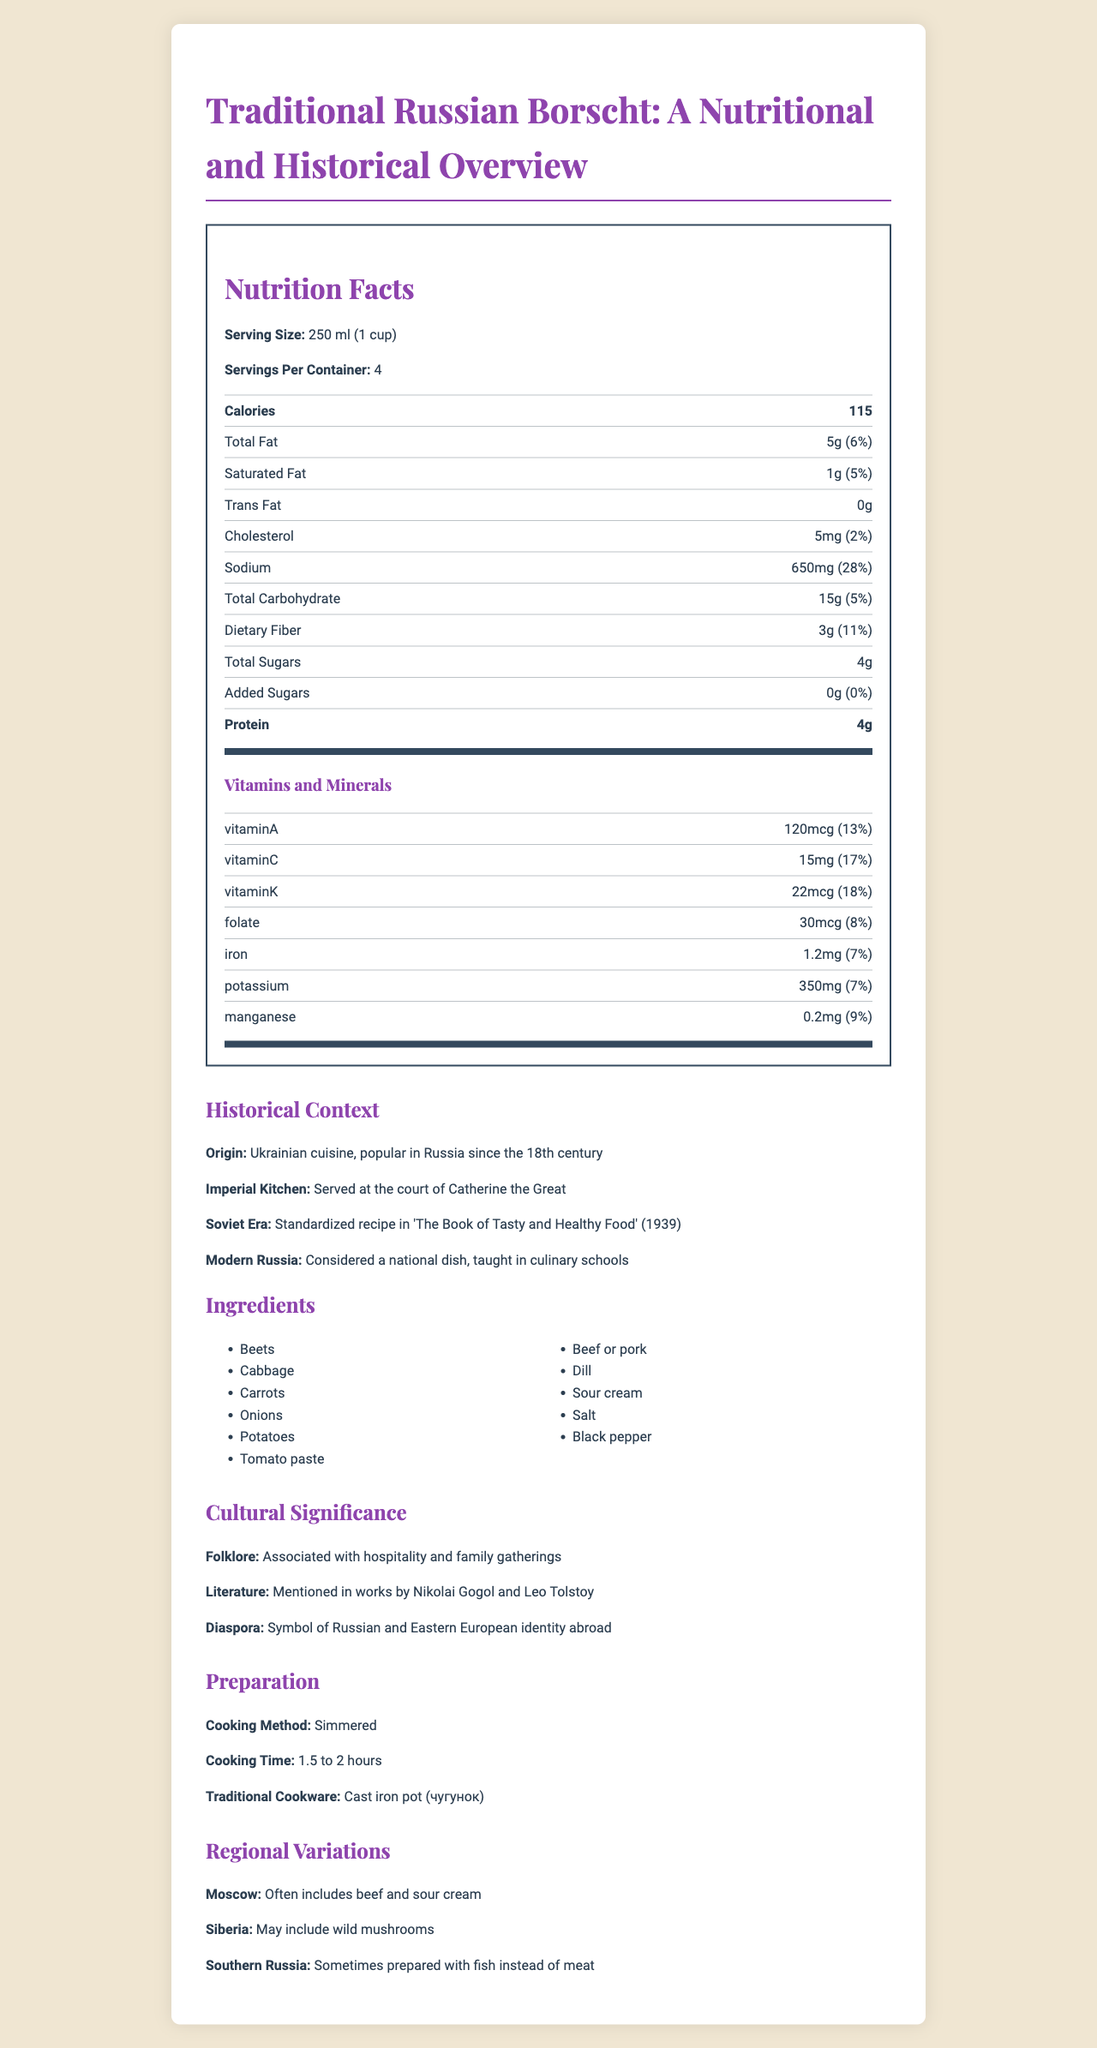What is the serving size of the traditional Russian borscht? The serving size is explicitly mentioned at the beginning of the nutrition facts section.
Answer: 250 ml (1 cup) How many servings are there per container? The nutrition facts label mentions that there are 4 servings per container.
Answer: 4 What is the calorie count per serving of borscht? The calorie count is listed as 115 calories per serving.
Answer: 115 What percentage of the daily value of Vitamin C does a serving of borscht provide? The nutrition label lists Vitamin C as providing 17% of the daily value.
Answer: 17% How much sodium is there per serving? The sodium content per serving is listed as 650mg.
Answer: 650mg Name two main ingredients of traditional Russian borscht. Both Beets and Cabbage are listed among the ingredients.
Answer: Beets and Cabbage What is the cooking time for traditional Russian borscht? The preparation section states that the cooking time is 1.5 to 2 hours.
Answer: 1.5 to 2 hours In which historical era was a standardized recipe of borscht included in 'The Book of Tasty and Healthy Food'? A. Imperial Kitchen B. Soviet Era C. Modern Russia The document mentions that the standardized recipe was included in 'The Book of Tasty and Healthy Food' during the Soviet Era (1939).
Answer: B Which vitamin has the highest percentage of the daily value per serving in the borscht? A. Vitamin A B. Vitamin C C. Vitamin K D. Folate Vitamin K has the highest percentage at 18% of the daily value per serving.
Answer: C Does the traditional Russian borscht contain any trans fat? (Yes/No) The nutrition label explicitly states that the borscht contains 0g of trans fat.
Answer: No Summarize the entire document. The summary captures the document's main sections, including nutritional details, historical and cultural context, ingredients, preparation, and regional variations.
Answer: The document provides a comprehensive breakdown of the nutrition facts for traditional Russian borscht, including serving size, calorie count, and details on fats, cholesterol, sodium, carbohydrates, fibers, sugars, proteins, vitamins, and minerals. It also includes historical context about the dish's origin, its significance during different historical periods, the cultural importance, and ingredients. Additionally, the preparation method, cooking time, traditional cookware, and regional variations are discussed. How much total carbohydrate is there per serving? The nutrition label shows that total carbohydrate content per serving is 15g.
Answer: 15g Which other historical figures mentioned the dish in their works, apart from Nikolai Gogol? The cultural significance section mentions that both Nikolai Gogol and Leo Tolstoy mentioned the dish.
Answer: Leo Tolstoy Can the specific modern-day price of borscht be found in the document? The document does not provide any information about the pricing of borscht.
Answer: Not enough information What folklore is associated with the traditional Russian borscht according to the document? The cultural significance section states that borscht is associated with hospitality and family gatherings.
Answer: Associated with hospitality and family gatherings Which regional variation of borscht often includes beef and sour cream? The regional variations section mentions that the Moscow variation often includes beef and sour cream.
Answer: Moscow 